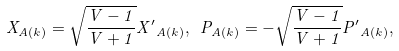<formula> <loc_0><loc_0><loc_500><loc_500>X _ { A ( k ) } = \sqrt { \frac { V - 1 } { V + 1 } } { X ^ { \prime } } _ { A ( k ) } , \ P _ { A ( k ) } = - \sqrt { \frac { V - 1 } { V + 1 } } { P ^ { \prime } } _ { A ( k ) } ,</formula> 